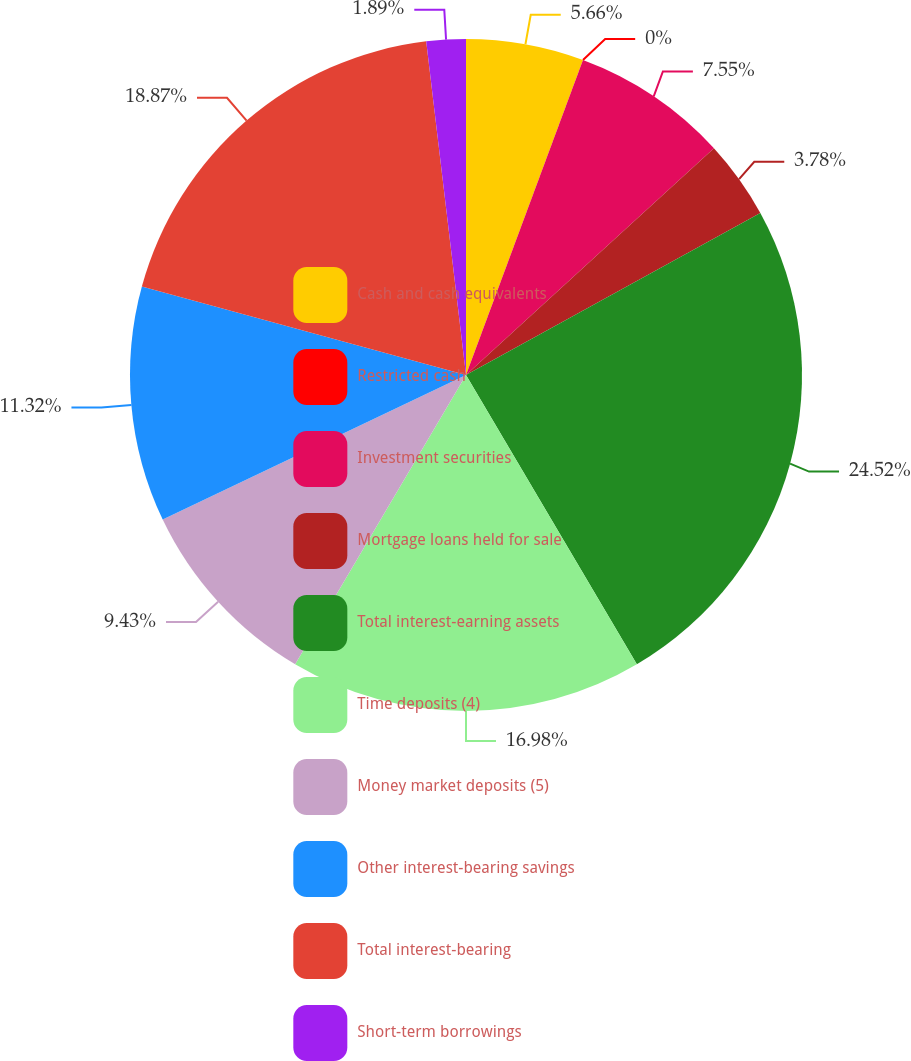<chart> <loc_0><loc_0><loc_500><loc_500><pie_chart><fcel>Cash and cash equivalents<fcel>Restricted cash<fcel>Investment securities<fcel>Mortgage loans held for sale<fcel>Total interest-earning assets<fcel>Time deposits (4)<fcel>Money market deposits (5)<fcel>Other interest-bearing savings<fcel>Total interest-bearing<fcel>Short-term borrowings<nl><fcel>5.66%<fcel>0.0%<fcel>7.55%<fcel>3.78%<fcel>24.52%<fcel>16.98%<fcel>9.43%<fcel>11.32%<fcel>18.87%<fcel>1.89%<nl></chart> 